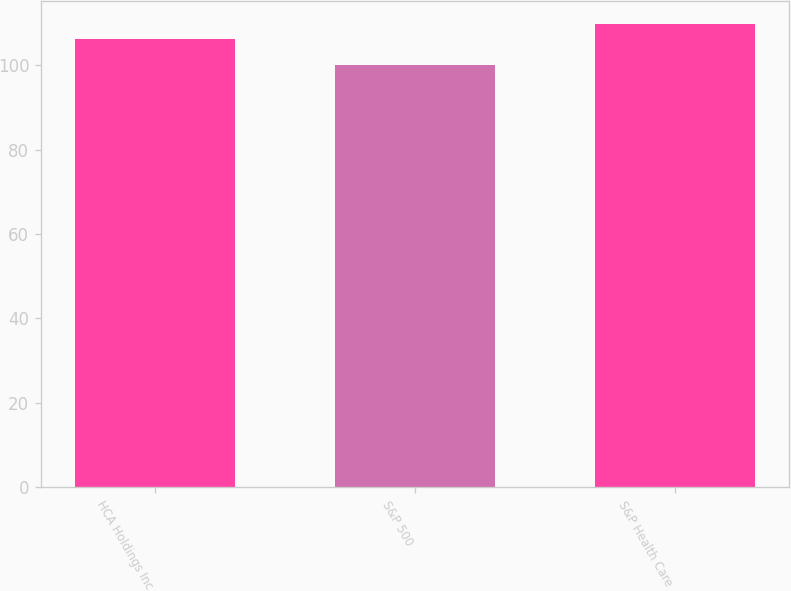Convert chart. <chart><loc_0><loc_0><loc_500><loc_500><bar_chart><fcel>HCA Holdings Inc<fcel>S&P 500<fcel>S&P Health Care<nl><fcel>106.38<fcel>100.14<fcel>109.91<nl></chart> 